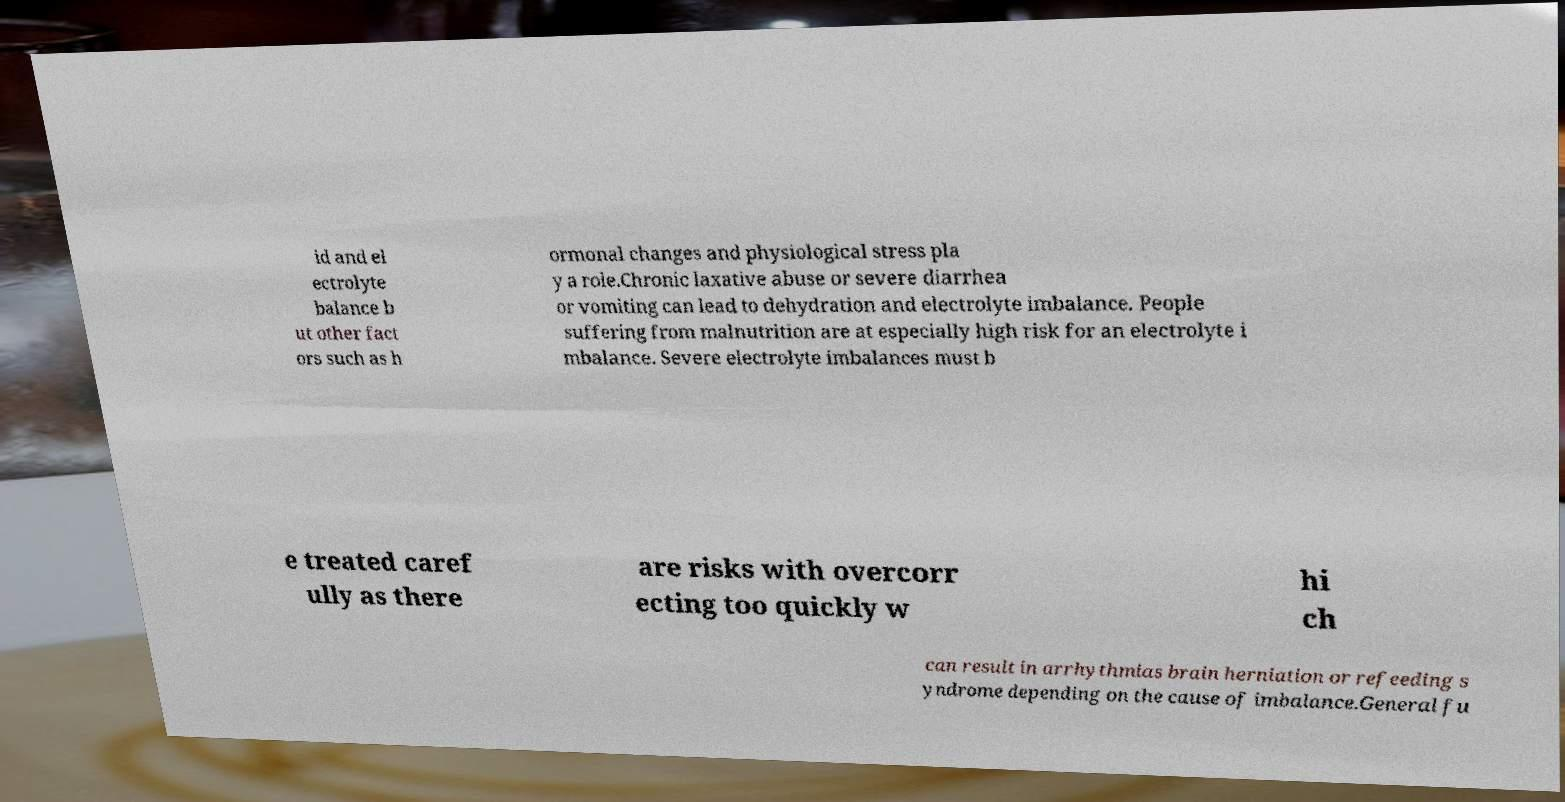Could you assist in decoding the text presented in this image and type it out clearly? id and el ectrolyte balance b ut other fact ors such as h ormonal changes and physiological stress pla y a role.Chronic laxative abuse or severe diarrhea or vomiting can lead to dehydration and electrolyte imbalance. People suffering from malnutrition are at especially high risk for an electrolyte i mbalance. Severe electrolyte imbalances must b e treated caref ully as there are risks with overcorr ecting too quickly w hi ch can result in arrhythmias brain herniation or refeeding s yndrome depending on the cause of imbalance.General fu 